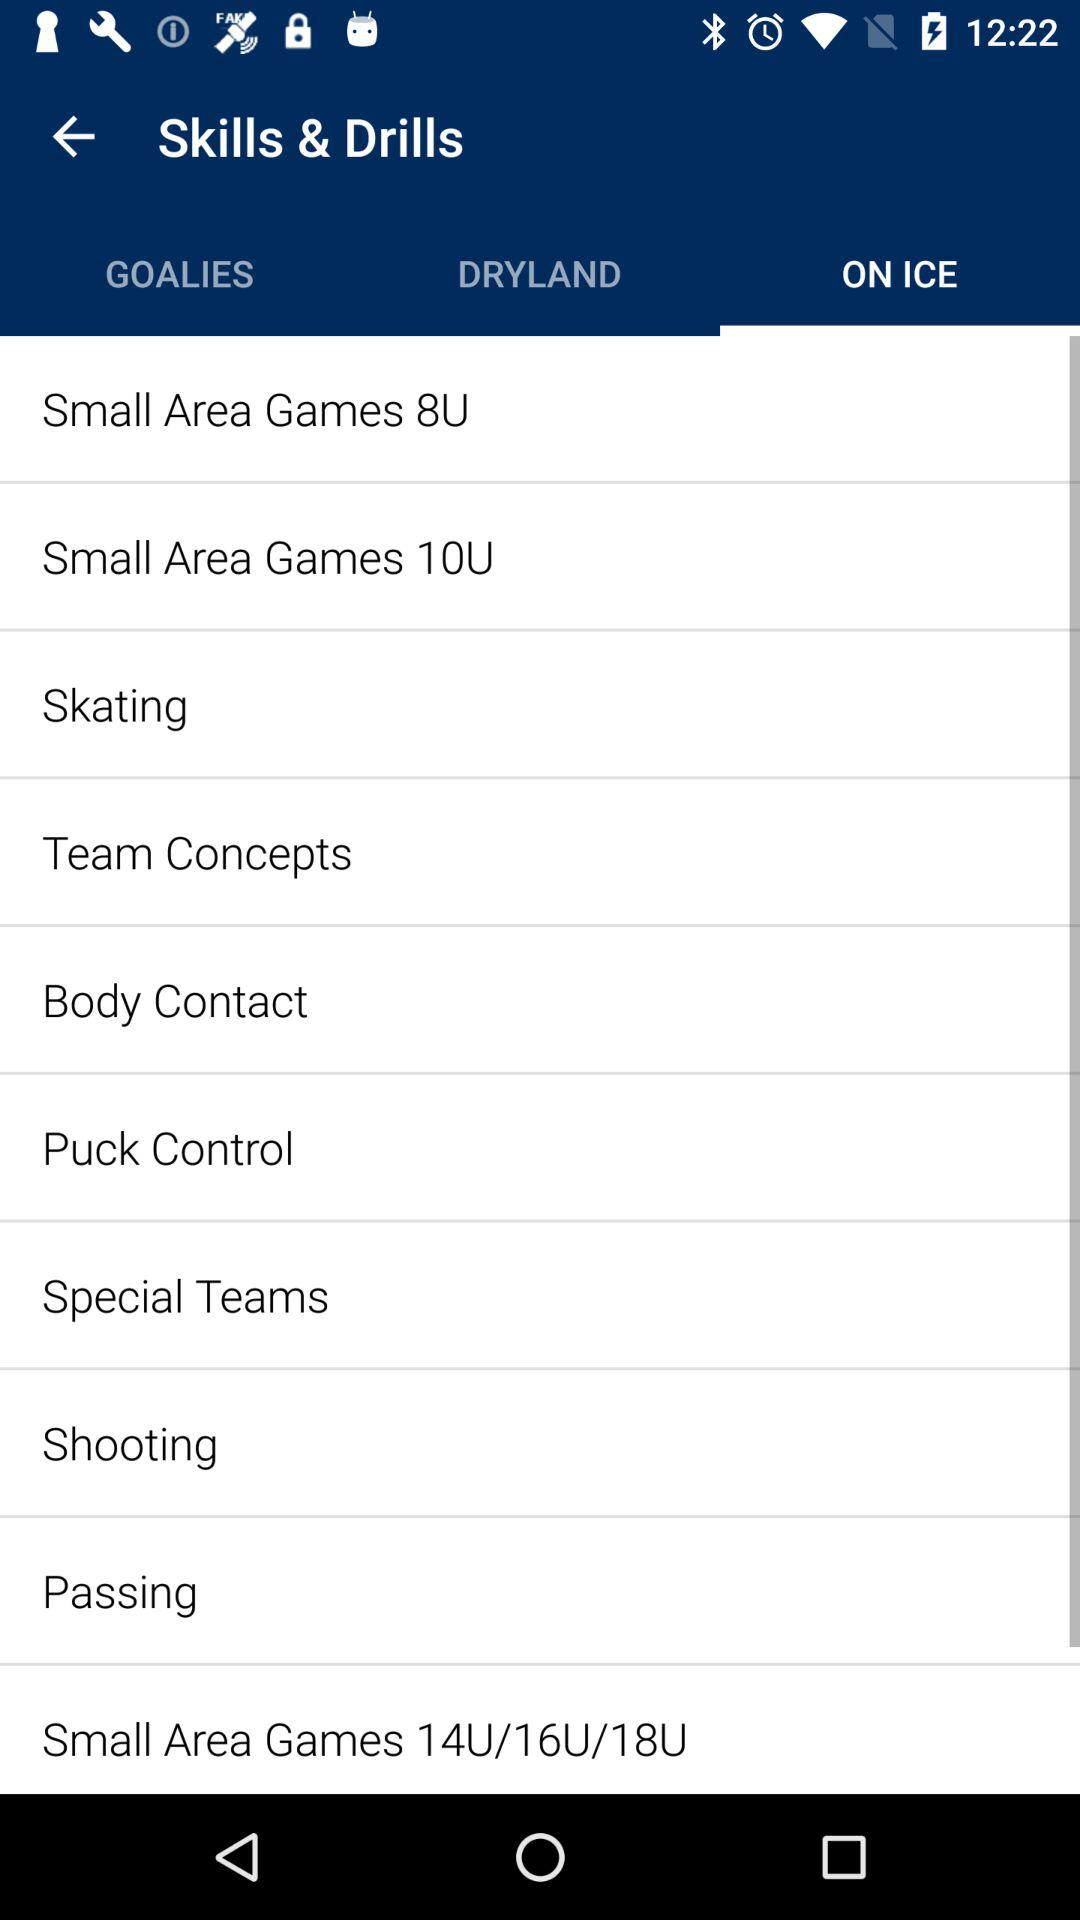Which option is selected? The selected option is "ON ICE". 